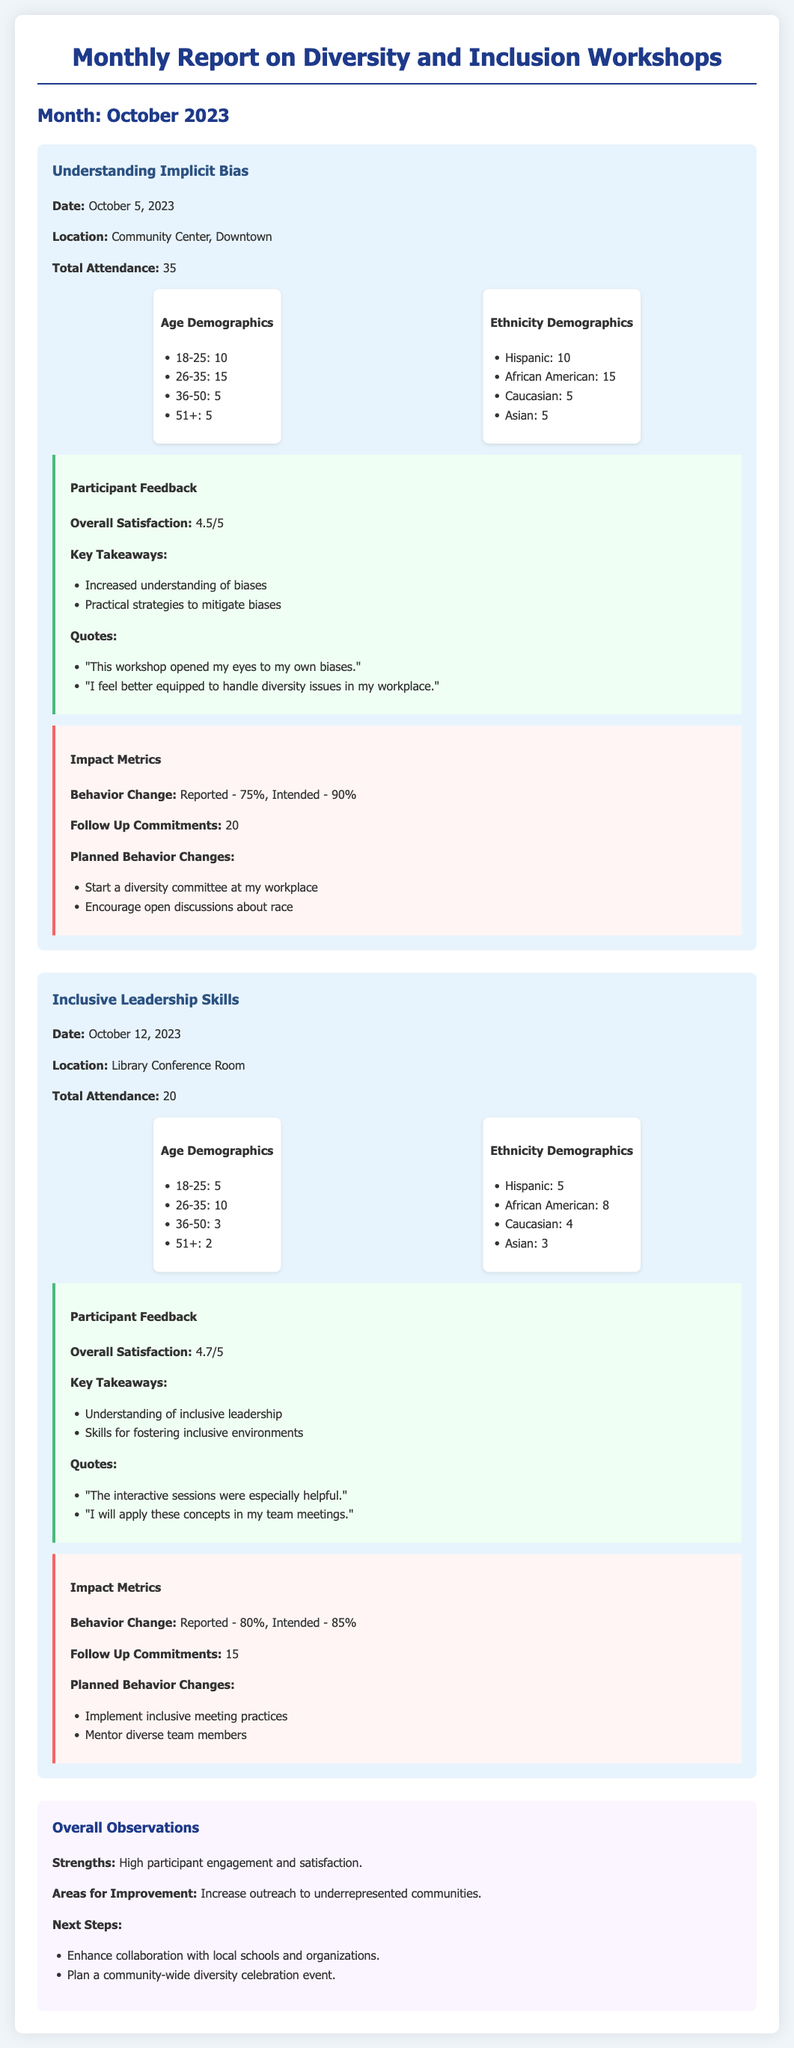What is the date of the "Understanding Implicit Bias" workshop? The date of the workshop is stated in the document under its title.
Answer: October 5, 2023 How many participants attended the "Inclusive Leadership Skills" workshop? The attendance for this workshop is provided in the event details section.
Answer: 20 What was the overall satisfaction rating for the "Understanding Implicit Bias" workshop? The satisfaction rating is listed in the participant feedback section of the workshop details.
Answer: 4.5/5 What is the total number of follow-up commitments reported in the "Understanding Implicit Bias" workshop? The document specifies the follow-up commitments in the impact metrics section.
Answer: 20 Which demographic group had the highest representation in the "Inclusive Leadership Skills" workshop? The ethnic demographics indicate the highest number in the list provided.
Answer: African American What two planned behavior changes were mentioned by participants of the "Understanding Implicit Bias" workshop? The planned behavior changes are listed under the impact metrics section for this workshop.
Answer: Start a diversity committee at my workplace; Encourage open discussions about race Which workshop had a higher reported behavior change percentage, "Understanding Implicit Bias" or "Inclusive Leadership Skills"? The behavior change percentages for both workshops are found under their respective impact metrics.
Answer: Inclusive Leadership Skills (80%) What is one area for improvement noted in the overall observations? The document outlines areas for improvement in the overall observations section, identifying something that needs attention.
Answer: Increase outreach to underrepresented communities What is the location of the "Understanding Implicit Bias" workshop? The location is mentioned in the workshop details section.
Answer: Community Center, Downtown 